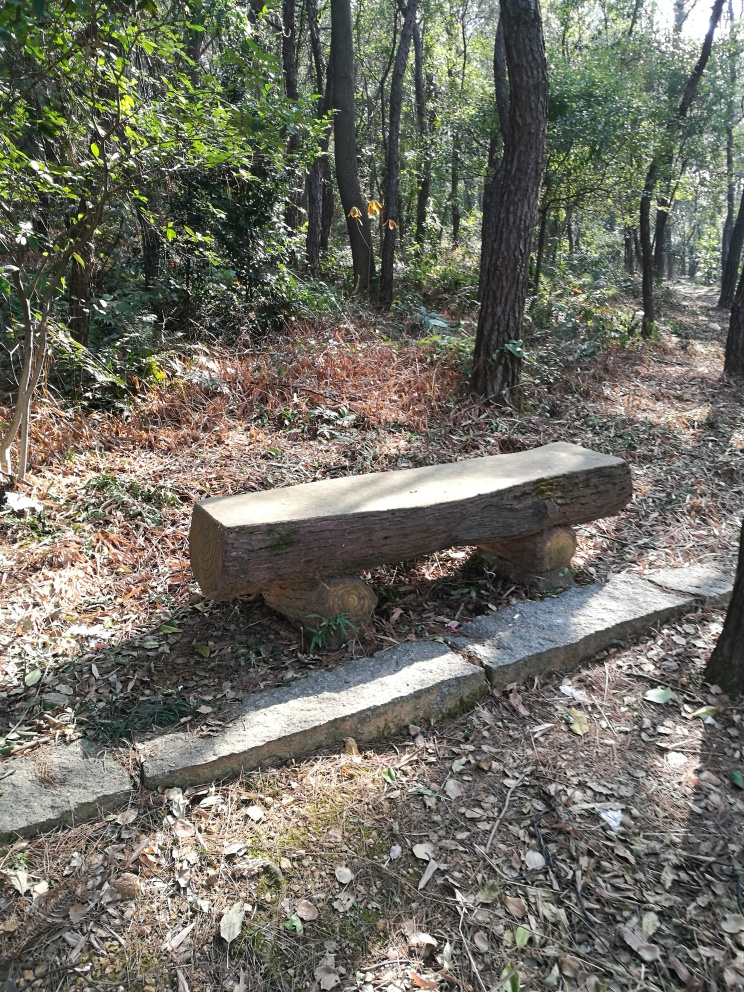Can you tell me something about the forest ecology visible in the image? Certainly! The forest appears to be a deciduous woodland, indicated by the leaf litter on the ground and the mixture of leafy and bare branches. This suggests it might be either early spring or late autumn. The variety of tree sizes indicates a naturally regenerating forest with a diverse age structure. 